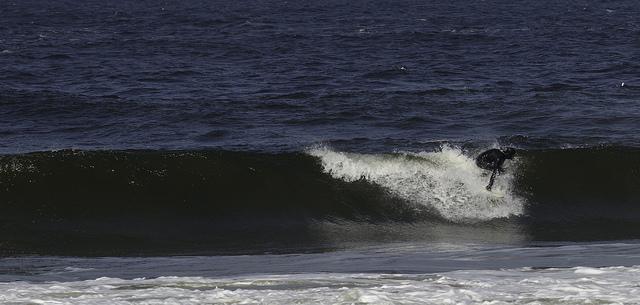Is this person a novice?
Quick response, please. No. How is he riding the wave?
Keep it brief. Surfboard. What color is his wetsuit?
Keep it brief. Black. 